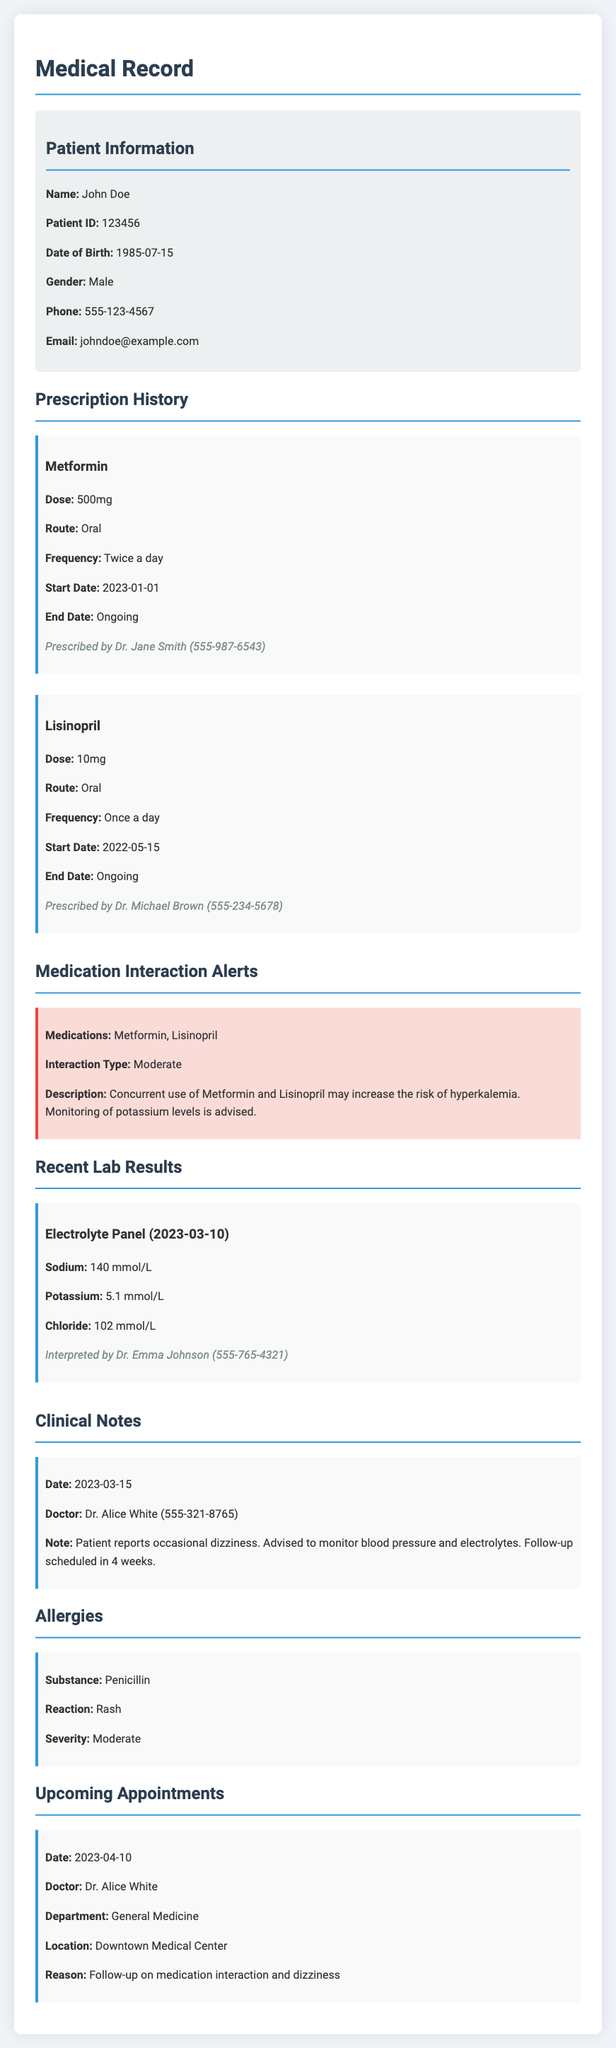What is the patient's name? The patient's name is stated in the patient information section of the document.
Answer: John Doe What medication is prescribed for the patient? The prescribed medications are listed in the prescription history section of the document.
Answer: Metformin, Lisinopril What is the dose of Lisinopril? The dose of Lisinopril is provided in the prescription details for that medication.
Answer: 10mg What is the interaction type between Metformin and Lisinopril? The interaction type is described in the medication interaction alerts section.
Answer: Moderate When is the next appointment scheduled? The next appointment date is indicated in the appointments section of the document.
Answer: 2023-04-10 Who interpreted the recent lab results? The interpreter of the lab results is mentioned in the lab results section of the document.
Answer: Dr. Emma Johnson What was the potassium level in the recent electrolyte panel? The potassium level is part of the lab results and is specifically mentioned there.
Answer: 5.1 mmol/L What allergy does the patient have? The allergies of the patient are listed in the allergies section of the document.
Answer: Penicillin What recommendation was made for the patient regarding dizziness? The recommendation regarding dizziness is included in the clinical notes section of the document.
Answer: Monitor blood pressure and electrolytes 